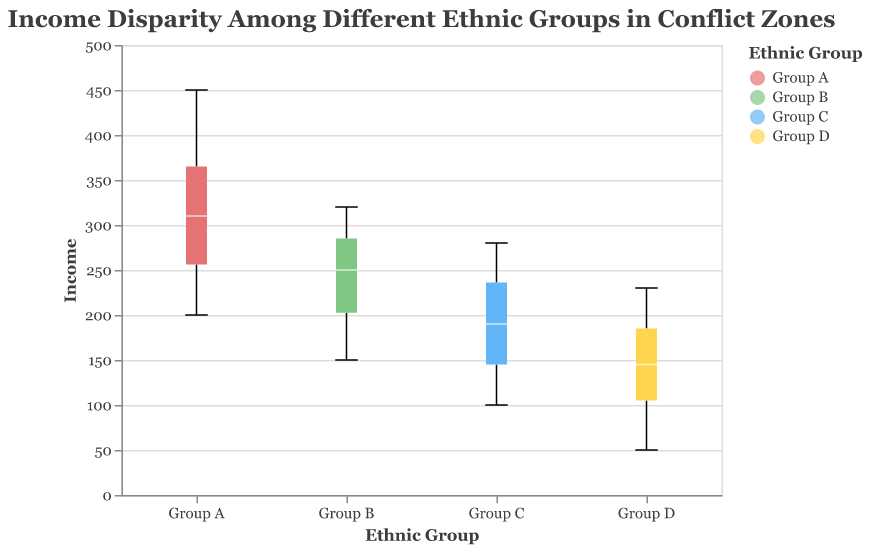what is the title of the figure? The title of the figure is generally found at the top and describes the main subject of the visualization. In this case, it’s "Income Disparity Among Different Ethnic Groups in Conflict Zones".
Answer: Income Disparity Among Different Ethnic Groups in Conflict Zones what do the colors represent? The colors in the plot correspond to different ethnic groups. For example, red might represent Group A, green might represent Group B, blue might represent Group C, and yellow might represent Group D.
Answer: Ethnic Groups what is the median income for Group A? The median income is represented by a horizontal line inside the box of the boxplot. For Group A, this line is around 310.
Answer: 310 which group has the lowest median income? The lowest median income can be determined by comparing the horizontal lines inside each boxplot. Group D has the lowest median income, which is around 130.
Answer: Group D how does the income range for Group B compare to Group C? The income range can be determined by looking at the top and bottom edges (whiskers) of each boxplot. Group B's income range is from 150 to 320, while Group C's income range is from 100 to 280.
Answer: Group B has a wider range which group has the highest maximum income, and what is it? The maximum income is represented by the top whisker on the boxplot. Group A has the highest maximum income, around 450.
Answer: Group A, 450 how does the interquartile range of Group D compare to Group A? The interquartile range (IQR) is the area between the bottom and top edges of the box. Group D's IQR is smaller than Group A's IQR, indicating less income variability within Group D.
Answer: Group D's IQR is smaller are there any outliers in the data for Group C? Outliers are typically represented by individual points outside the whiskers. There are no individual points outside the whiskers for Group C, indicating no outliers.
Answer: No what insights about income disparity in conflict zones can be deduced from this plot? The plot shows significant income disparities between the groups, with Group A having the highest income levels and Group D having the lowest. The variability of incomes within groups also varies, suggesting different levels of economic inequality within each group.
Answer: Significant disparities, varying intra-group variability which group has the widest income range, and what is the range? The widest income range is indicated by the length of the whiskers. Group A has the widest income range, from 200 to 450, making a range of 250.
Answer: Group A, 250 